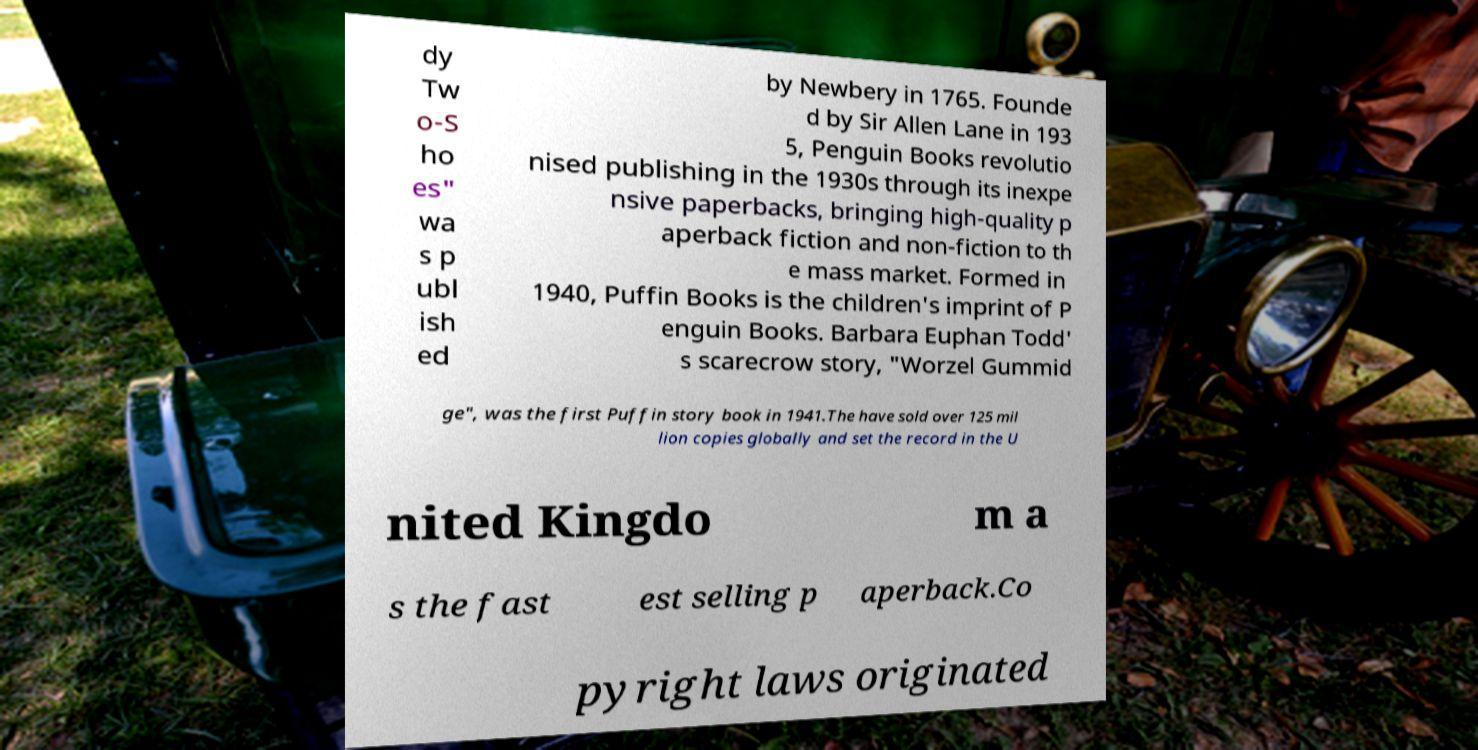Can you accurately transcribe the text from the provided image for me? dy Tw o-S ho es" wa s p ubl ish ed by Newbery in 1765. Founde d by Sir Allen Lane in 193 5, Penguin Books revolutio nised publishing in the 1930s through its inexpe nsive paperbacks, bringing high-quality p aperback fiction and non-fiction to th e mass market. Formed in 1940, Puffin Books is the children's imprint of P enguin Books. Barbara Euphan Todd' s scarecrow story, "Worzel Gummid ge", was the first Puffin story book in 1941.The have sold over 125 mil lion copies globally and set the record in the U nited Kingdo m a s the fast est selling p aperback.Co pyright laws originated 